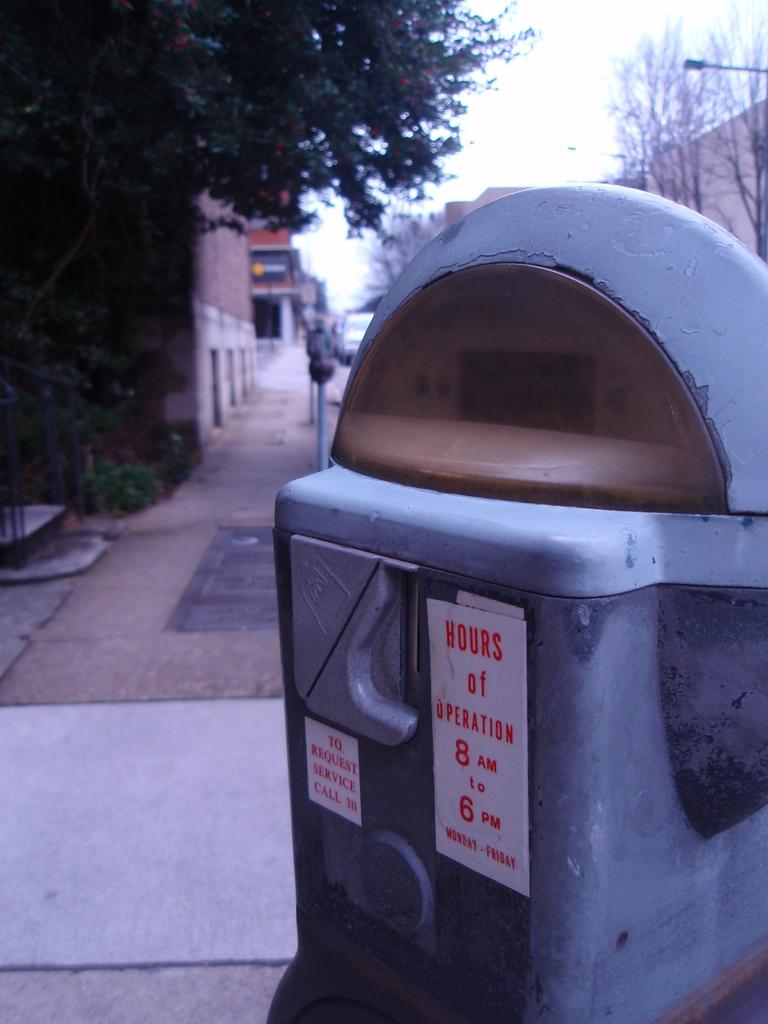<image>
Summarize the visual content of the image. A parking meter showing hours of operation are from 8am to 6pm 